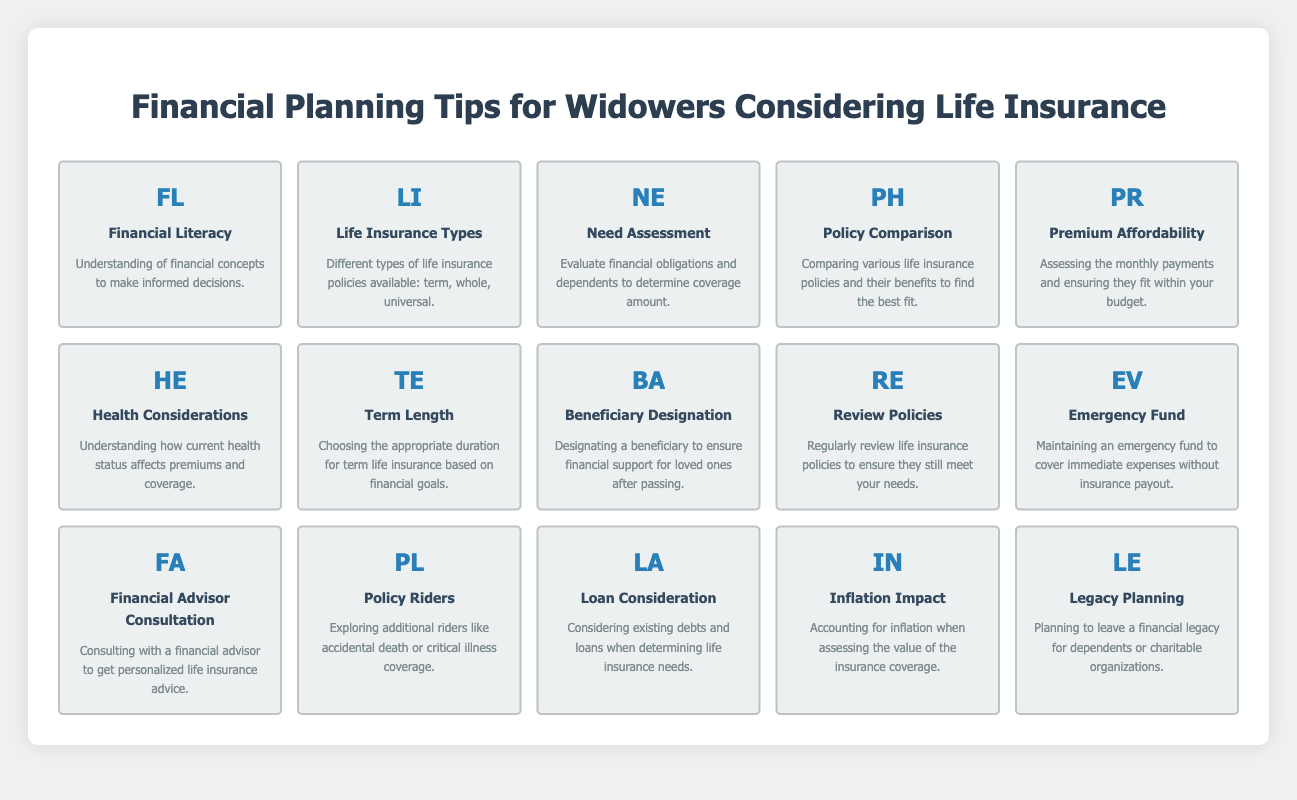What are the types of life insurance mentioned in the table? The table lists a specific element with the symbol "LI", which stands for "Life Insurance Types". The description indicates that it includes different types of life insurance policies available: term, whole, and universal.
Answer: Term, whole, universal How can financial obligations impact life insurance need assessment? The element with symbol "NE" in the table signifies "Need Assessment". Its description explains that evaluating financial obligations and dependents is crucial for determining the amount of coverage necessary. Financial obligations inform how much coverage is needed to secure the family’s financial future after someone's passing.
Answer: Evaluating financial obligations is crucial for determining coverage Is there a recommendation for regularly reviewing life insurance policies? The entry with the symbol "RE" indicates "Review Policies". The description confirms that it's important to regularly review life insurance policies to ensure they still meet your needs, which implies a yes.
Answer: Yes What factors should be considered when assessing premium affordability? The table contains an element labeled "PR", which deals with "Premium Affordability". This element emphasizes the need to assess monthly payments and confirm they fit within your budget. Therefore, budgeting plays a key role in this assessment.
Answer: Monthly payments and budget What is the importance of designating a beneficiary in life insurance? The "BA" symbol stands for "Beneficiary Designation". Its description highlights the importance of this action, as it ensures financial support for loved ones after passing, which shows the necessity of this decision in financial planning.
Answer: Ensures financial support for loved ones If costs are increasing due to inflation, does this affect life insurance coverage needs? The element with symbol "IN" signifies "Inflation Impact". The description states the necessity of accounting for inflation when assessing the value of insurance coverage, which implies inflation does impact coverage needs.
Answer: Yes, inflation affects coverage needs What would happen if a person does not maintain an emergency fund while relying on life insurance? The "EV" element represents "Emergency Fund" and suggests maintaining an emergency fund for immediate expenses without insurance payout. Lack of such a fund could lead to financial instability before insurance claims are settled, suggesting it's vital to have it.
Answer: Financial instability may occur without an emergency fund How does health status influence life insurance premiums? The "HE" symbol corresponds to "Health Considerations". The description indicates understanding current health status is vital as it directly affects premiums and coverage, suggesting that a person's health will influence the cost of insurance.
Answer: Health status affects premiums What should a widower consider regarding existing debts in their life insurance planning? The "LA" entry denotes "Loan Consideration". The description indicates that existing debts and loans should be considered when determining life insurance needs, showing that debts are a critical part of financial planning to ensure dependents are supported.
Answer: Existing debts impact insurance needs 